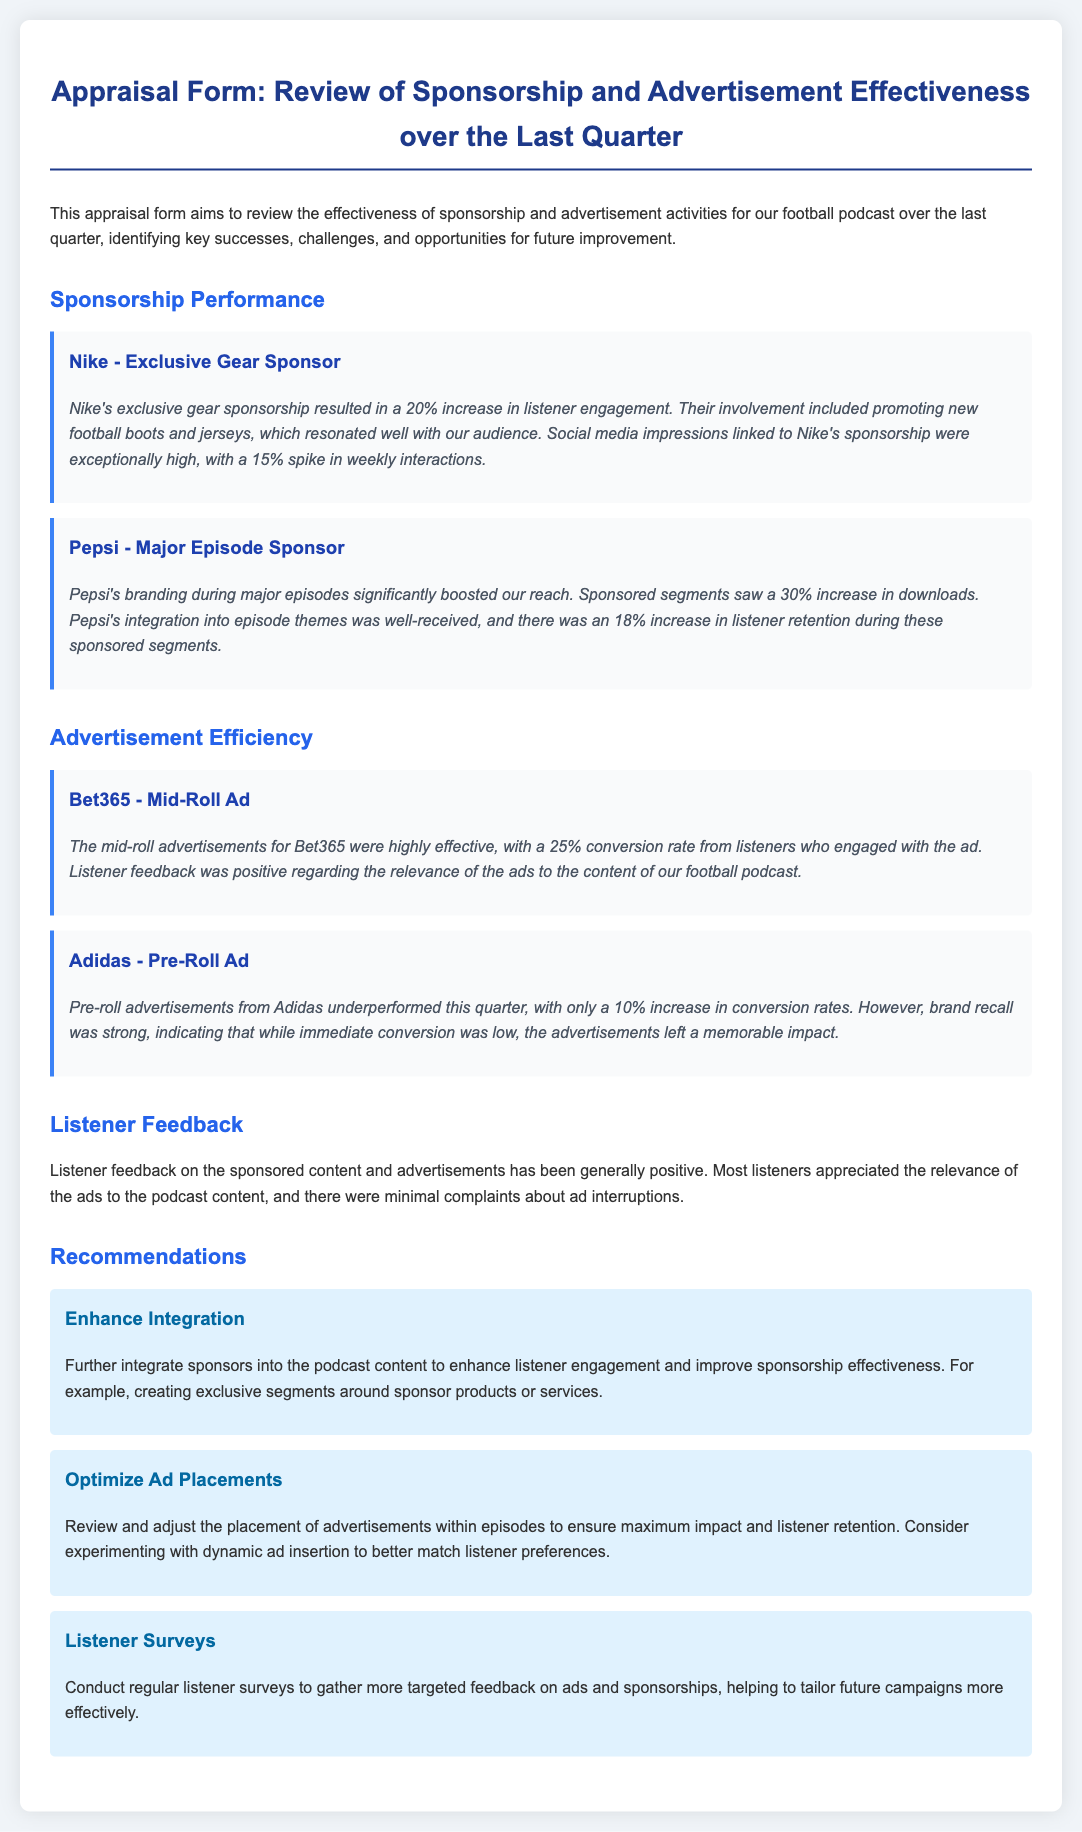What was the increase in listener engagement from Nike's sponsorship? The document states that Nike's sponsorship resulted in a 20% increase in listener engagement.
Answer: 20% What was the percentage increase in downloads for episodes sponsored by Pepsi? According to the document, Pepsi's sponsored segments saw a 30% increase in downloads.
Answer: 30% How effective was Bet365's mid-roll advertisement in terms of conversion rate? The effectiveness of Bet365's mid-roll ad is indicated by a 25% conversion rate from listeners.
Answer: 25% What was the conversion rate for Adidas' pre-roll advertisements? The document mentions that Adidas had only a 10% increase in conversion rates.
Answer: 10% What feedback did listeners generally give about the sponsored content and advertisements? The overall feedback was generally positive regarding the relevance of the ads to the podcast content.
Answer: Positive What recommendation is given for enhancing listener engagement with sponsors? The document suggests further integration of sponsors into the podcast content.
Answer: Enhance Integration How does the document propose to optimize the placement of advertisements? It suggests reviewing and adjusting the placement of advertisements within episodes.
Answer: Optimize Ad Placements What is suggested to better tailor future campaigns? The document recommends conducting regular listener surveys for targeted feedback.
Answer: Listener Surveys 